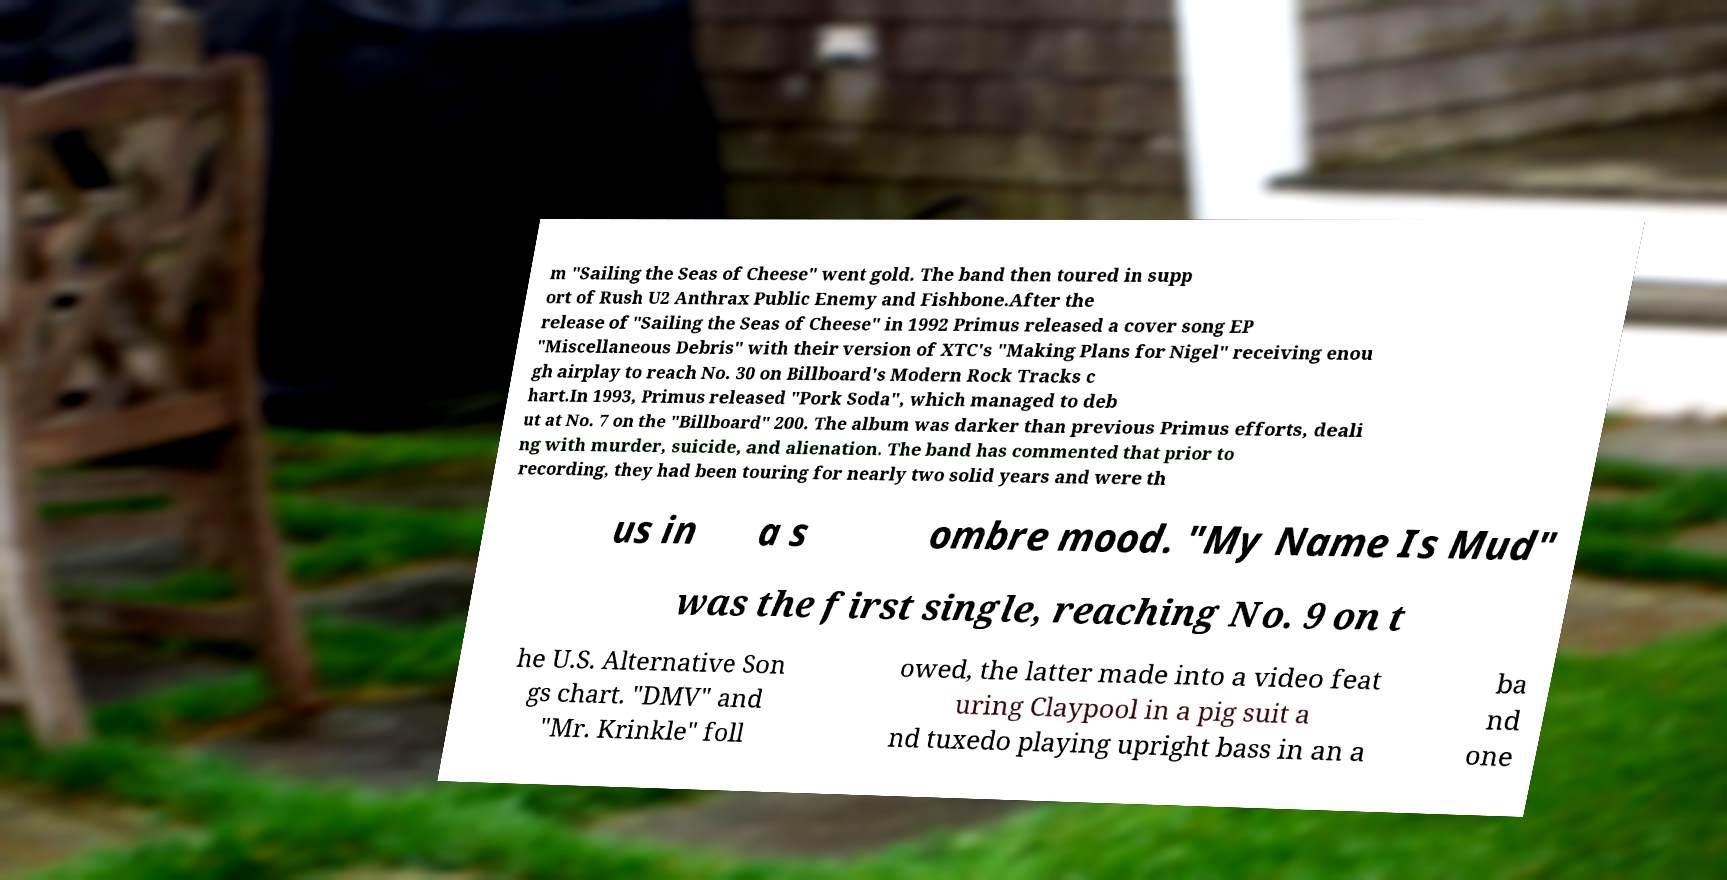There's text embedded in this image that I need extracted. Can you transcribe it verbatim? m "Sailing the Seas of Cheese" went gold. The band then toured in supp ort of Rush U2 Anthrax Public Enemy and Fishbone.After the release of "Sailing the Seas of Cheese" in 1992 Primus released a cover song EP "Miscellaneous Debris" with their version of XTC's "Making Plans for Nigel" receiving enou gh airplay to reach No. 30 on Billboard's Modern Rock Tracks c hart.In 1993, Primus released "Pork Soda", which managed to deb ut at No. 7 on the "Billboard" 200. The album was darker than previous Primus efforts, deali ng with murder, suicide, and alienation. The band has commented that prior to recording, they had been touring for nearly two solid years and were th us in a s ombre mood. "My Name Is Mud" was the first single, reaching No. 9 on t he U.S. Alternative Son gs chart. "DMV" and "Mr. Krinkle" foll owed, the latter made into a video feat uring Claypool in a pig suit a nd tuxedo playing upright bass in an a ba nd one 